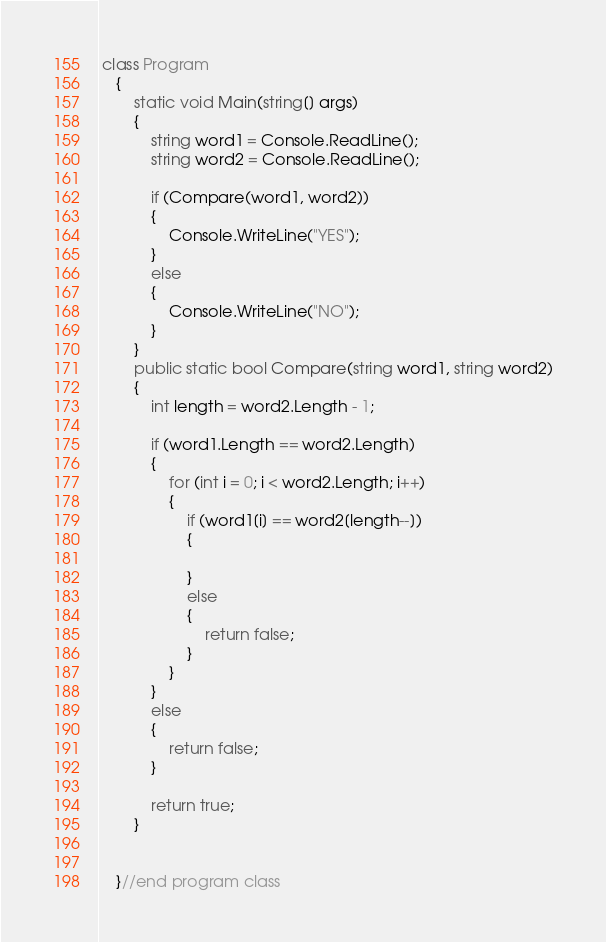Convert code to text. <code><loc_0><loc_0><loc_500><loc_500><_C#_> class Program
    {
        static void Main(string[] args)
        {
            string word1 = Console.ReadLine();
            string word2 = Console.ReadLine();

            if (Compare(word1, word2))
            {
                Console.WriteLine("YES");
            }
            else
            {
                Console.WriteLine("NO");
            }
        }
        public static bool Compare(string word1, string word2)
        {
            int length = word2.Length - 1;
       
            if (word1.Length == word2.Length)
            {
                for (int i = 0; i < word2.Length; i++)
                {
                    if (word1[i] == word2[length--])
                    {

                    }
                    else
                    {
                        return false;
                    }
                }
            }
            else
            {
                return false;
            }

            return true;
        }


    }//end program class</code> 